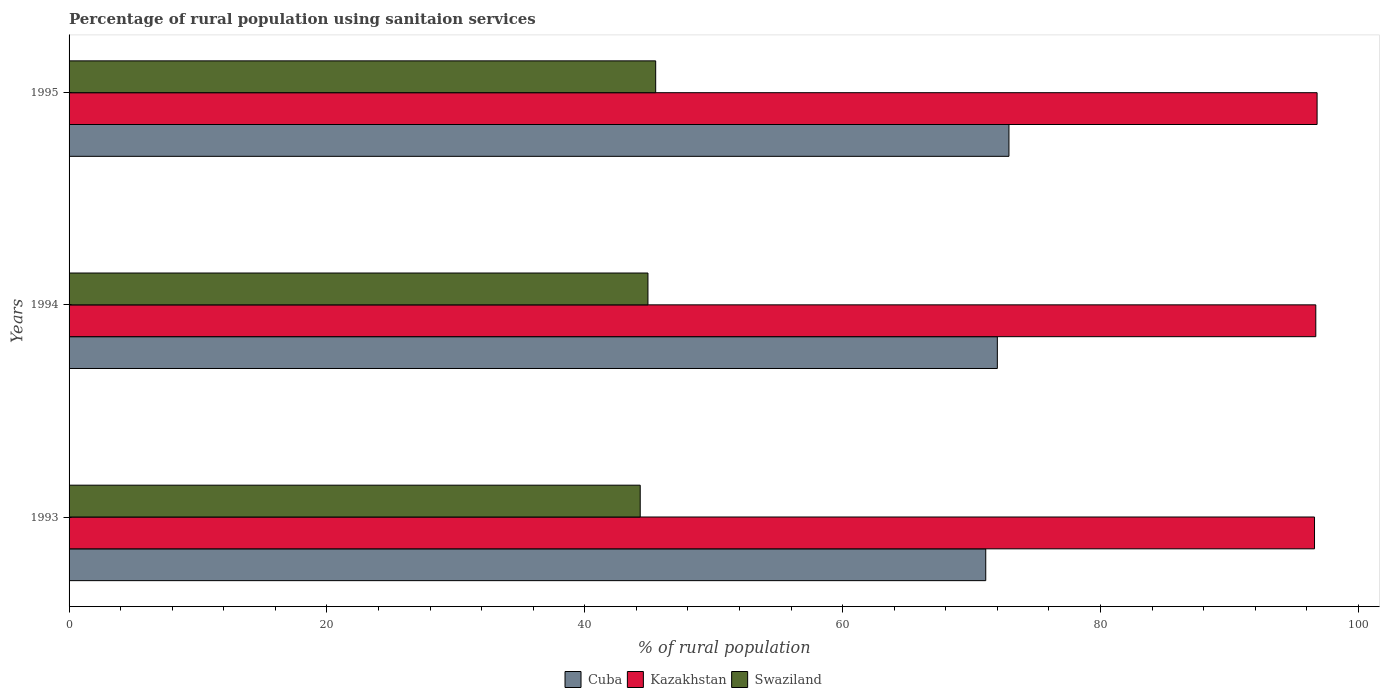Are the number of bars on each tick of the Y-axis equal?
Provide a succinct answer. Yes. How many bars are there on the 2nd tick from the bottom?
Give a very brief answer. 3. What is the label of the 2nd group of bars from the top?
Your answer should be compact. 1994. What is the percentage of rural population using sanitaion services in Kazakhstan in 1994?
Keep it short and to the point. 96.7. Across all years, what is the maximum percentage of rural population using sanitaion services in Swaziland?
Your response must be concise. 45.5. Across all years, what is the minimum percentage of rural population using sanitaion services in Kazakhstan?
Ensure brevity in your answer.  96.6. In which year was the percentage of rural population using sanitaion services in Swaziland minimum?
Your response must be concise. 1993. What is the total percentage of rural population using sanitaion services in Cuba in the graph?
Provide a succinct answer. 216. What is the difference between the percentage of rural population using sanitaion services in Swaziland in 1993 and that in 1995?
Your response must be concise. -1.2. What is the difference between the percentage of rural population using sanitaion services in Cuba in 1993 and the percentage of rural population using sanitaion services in Kazakhstan in 1994?
Keep it short and to the point. -25.6. What is the average percentage of rural population using sanitaion services in Swaziland per year?
Offer a very short reply. 44.9. In the year 1994, what is the difference between the percentage of rural population using sanitaion services in Kazakhstan and percentage of rural population using sanitaion services in Cuba?
Your answer should be compact. 24.7. What is the ratio of the percentage of rural population using sanitaion services in Kazakhstan in 1993 to that in 1994?
Your answer should be compact. 1. Is the percentage of rural population using sanitaion services in Kazakhstan in 1993 less than that in 1994?
Keep it short and to the point. Yes. What is the difference between the highest and the second highest percentage of rural population using sanitaion services in Cuba?
Provide a succinct answer. 0.9. What is the difference between the highest and the lowest percentage of rural population using sanitaion services in Kazakhstan?
Give a very brief answer. 0.2. In how many years, is the percentage of rural population using sanitaion services in Kazakhstan greater than the average percentage of rural population using sanitaion services in Kazakhstan taken over all years?
Provide a succinct answer. 1. Is the sum of the percentage of rural population using sanitaion services in Kazakhstan in 1994 and 1995 greater than the maximum percentage of rural population using sanitaion services in Cuba across all years?
Ensure brevity in your answer.  Yes. What does the 1st bar from the top in 1994 represents?
Provide a succinct answer. Swaziland. What does the 3rd bar from the bottom in 1994 represents?
Offer a terse response. Swaziland. Is it the case that in every year, the sum of the percentage of rural population using sanitaion services in Kazakhstan and percentage of rural population using sanitaion services in Swaziland is greater than the percentage of rural population using sanitaion services in Cuba?
Offer a very short reply. Yes. Are all the bars in the graph horizontal?
Offer a very short reply. Yes. How many years are there in the graph?
Give a very brief answer. 3. Are the values on the major ticks of X-axis written in scientific E-notation?
Offer a very short reply. No. Does the graph contain any zero values?
Offer a terse response. No. Does the graph contain grids?
Give a very brief answer. No. How many legend labels are there?
Your answer should be compact. 3. How are the legend labels stacked?
Make the answer very short. Horizontal. What is the title of the graph?
Provide a succinct answer. Percentage of rural population using sanitaion services. Does "Korea (Republic)" appear as one of the legend labels in the graph?
Make the answer very short. No. What is the label or title of the X-axis?
Offer a terse response. % of rural population. What is the label or title of the Y-axis?
Offer a very short reply. Years. What is the % of rural population in Cuba in 1993?
Your answer should be very brief. 71.1. What is the % of rural population in Kazakhstan in 1993?
Your answer should be compact. 96.6. What is the % of rural population of Swaziland in 1993?
Offer a very short reply. 44.3. What is the % of rural population of Cuba in 1994?
Keep it short and to the point. 72. What is the % of rural population in Kazakhstan in 1994?
Provide a short and direct response. 96.7. What is the % of rural population of Swaziland in 1994?
Give a very brief answer. 44.9. What is the % of rural population of Cuba in 1995?
Provide a succinct answer. 72.9. What is the % of rural population in Kazakhstan in 1995?
Provide a succinct answer. 96.8. What is the % of rural population of Swaziland in 1995?
Give a very brief answer. 45.5. Across all years, what is the maximum % of rural population of Cuba?
Your response must be concise. 72.9. Across all years, what is the maximum % of rural population of Kazakhstan?
Ensure brevity in your answer.  96.8. Across all years, what is the maximum % of rural population of Swaziland?
Give a very brief answer. 45.5. Across all years, what is the minimum % of rural population in Cuba?
Your answer should be compact. 71.1. Across all years, what is the minimum % of rural population in Kazakhstan?
Offer a terse response. 96.6. Across all years, what is the minimum % of rural population in Swaziland?
Provide a short and direct response. 44.3. What is the total % of rural population in Cuba in the graph?
Your response must be concise. 216. What is the total % of rural population in Kazakhstan in the graph?
Your response must be concise. 290.1. What is the total % of rural population of Swaziland in the graph?
Make the answer very short. 134.7. What is the difference between the % of rural population of Cuba in 1993 and that in 1995?
Offer a terse response. -1.8. What is the difference between the % of rural population in Swaziland in 1993 and that in 1995?
Ensure brevity in your answer.  -1.2. What is the difference between the % of rural population of Cuba in 1994 and that in 1995?
Give a very brief answer. -0.9. What is the difference between the % of rural population of Kazakhstan in 1994 and that in 1995?
Give a very brief answer. -0.1. What is the difference between the % of rural population in Swaziland in 1994 and that in 1995?
Provide a short and direct response. -0.6. What is the difference between the % of rural population of Cuba in 1993 and the % of rural population of Kazakhstan in 1994?
Offer a very short reply. -25.6. What is the difference between the % of rural population in Cuba in 1993 and the % of rural population in Swaziland in 1994?
Your answer should be compact. 26.2. What is the difference between the % of rural population in Kazakhstan in 1993 and the % of rural population in Swaziland in 1994?
Keep it short and to the point. 51.7. What is the difference between the % of rural population of Cuba in 1993 and the % of rural population of Kazakhstan in 1995?
Offer a very short reply. -25.7. What is the difference between the % of rural population in Cuba in 1993 and the % of rural population in Swaziland in 1995?
Give a very brief answer. 25.6. What is the difference between the % of rural population in Kazakhstan in 1993 and the % of rural population in Swaziland in 1995?
Keep it short and to the point. 51.1. What is the difference between the % of rural population of Cuba in 1994 and the % of rural population of Kazakhstan in 1995?
Your response must be concise. -24.8. What is the difference between the % of rural population in Cuba in 1994 and the % of rural population in Swaziland in 1995?
Offer a terse response. 26.5. What is the difference between the % of rural population in Kazakhstan in 1994 and the % of rural population in Swaziland in 1995?
Your answer should be compact. 51.2. What is the average % of rural population in Cuba per year?
Make the answer very short. 72. What is the average % of rural population in Kazakhstan per year?
Give a very brief answer. 96.7. What is the average % of rural population of Swaziland per year?
Provide a succinct answer. 44.9. In the year 1993, what is the difference between the % of rural population in Cuba and % of rural population in Kazakhstan?
Offer a very short reply. -25.5. In the year 1993, what is the difference between the % of rural population in Cuba and % of rural population in Swaziland?
Make the answer very short. 26.8. In the year 1993, what is the difference between the % of rural population in Kazakhstan and % of rural population in Swaziland?
Offer a terse response. 52.3. In the year 1994, what is the difference between the % of rural population of Cuba and % of rural population of Kazakhstan?
Make the answer very short. -24.7. In the year 1994, what is the difference between the % of rural population in Cuba and % of rural population in Swaziland?
Offer a very short reply. 27.1. In the year 1994, what is the difference between the % of rural population in Kazakhstan and % of rural population in Swaziland?
Ensure brevity in your answer.  51.8. In the year 1995, what is the difference between the % of rural population in Cuba and % of rural population in Kazakhstan?
Make the answer very short. -23.9. In the year 1995, what is the difference between the % of rural population of Cuba and % of rural population of Swaziland?
Keep it short and to the point. 27.4. In the year 1995, what is the difference between the % of rural population in Kazakhstan and % of rural population in Swaziland?
Offer a terse response. 51.3. What is the ratio of the % of rural population of Cuba in 1993 to that in 1994?
Your answer should be very brief. 0.99. What is the ratio of the % of rural population of Swaziland in 1993 to that in 1994?
Provide a short and direct response. 0.99. What is the ratio of the % of rural population in Cuba in 1993 to that in 1995?
Keep it short and to the point. 0.98. What is the ratio of the % of rural population in Kazakhstan in 1993 to that in 1995?
Provide a succinct answer. 1. What is the ratio of the % of rural population of Swaziland in 1993 to that in 1995?
Keep it short and to the point. 0.97. What is the ratio of the % of rural population in Cuba in 1994 to that in 1995?
Keep it short and to the point. 0.99. What is the difference between the highest and the lowest % of rural population of Cuba?
Keep it short and to the point. 1.8. What is the difference between the highest and the lowest % of rural population in Kazakhstan?
Keep it short and to the point. 0.2. 